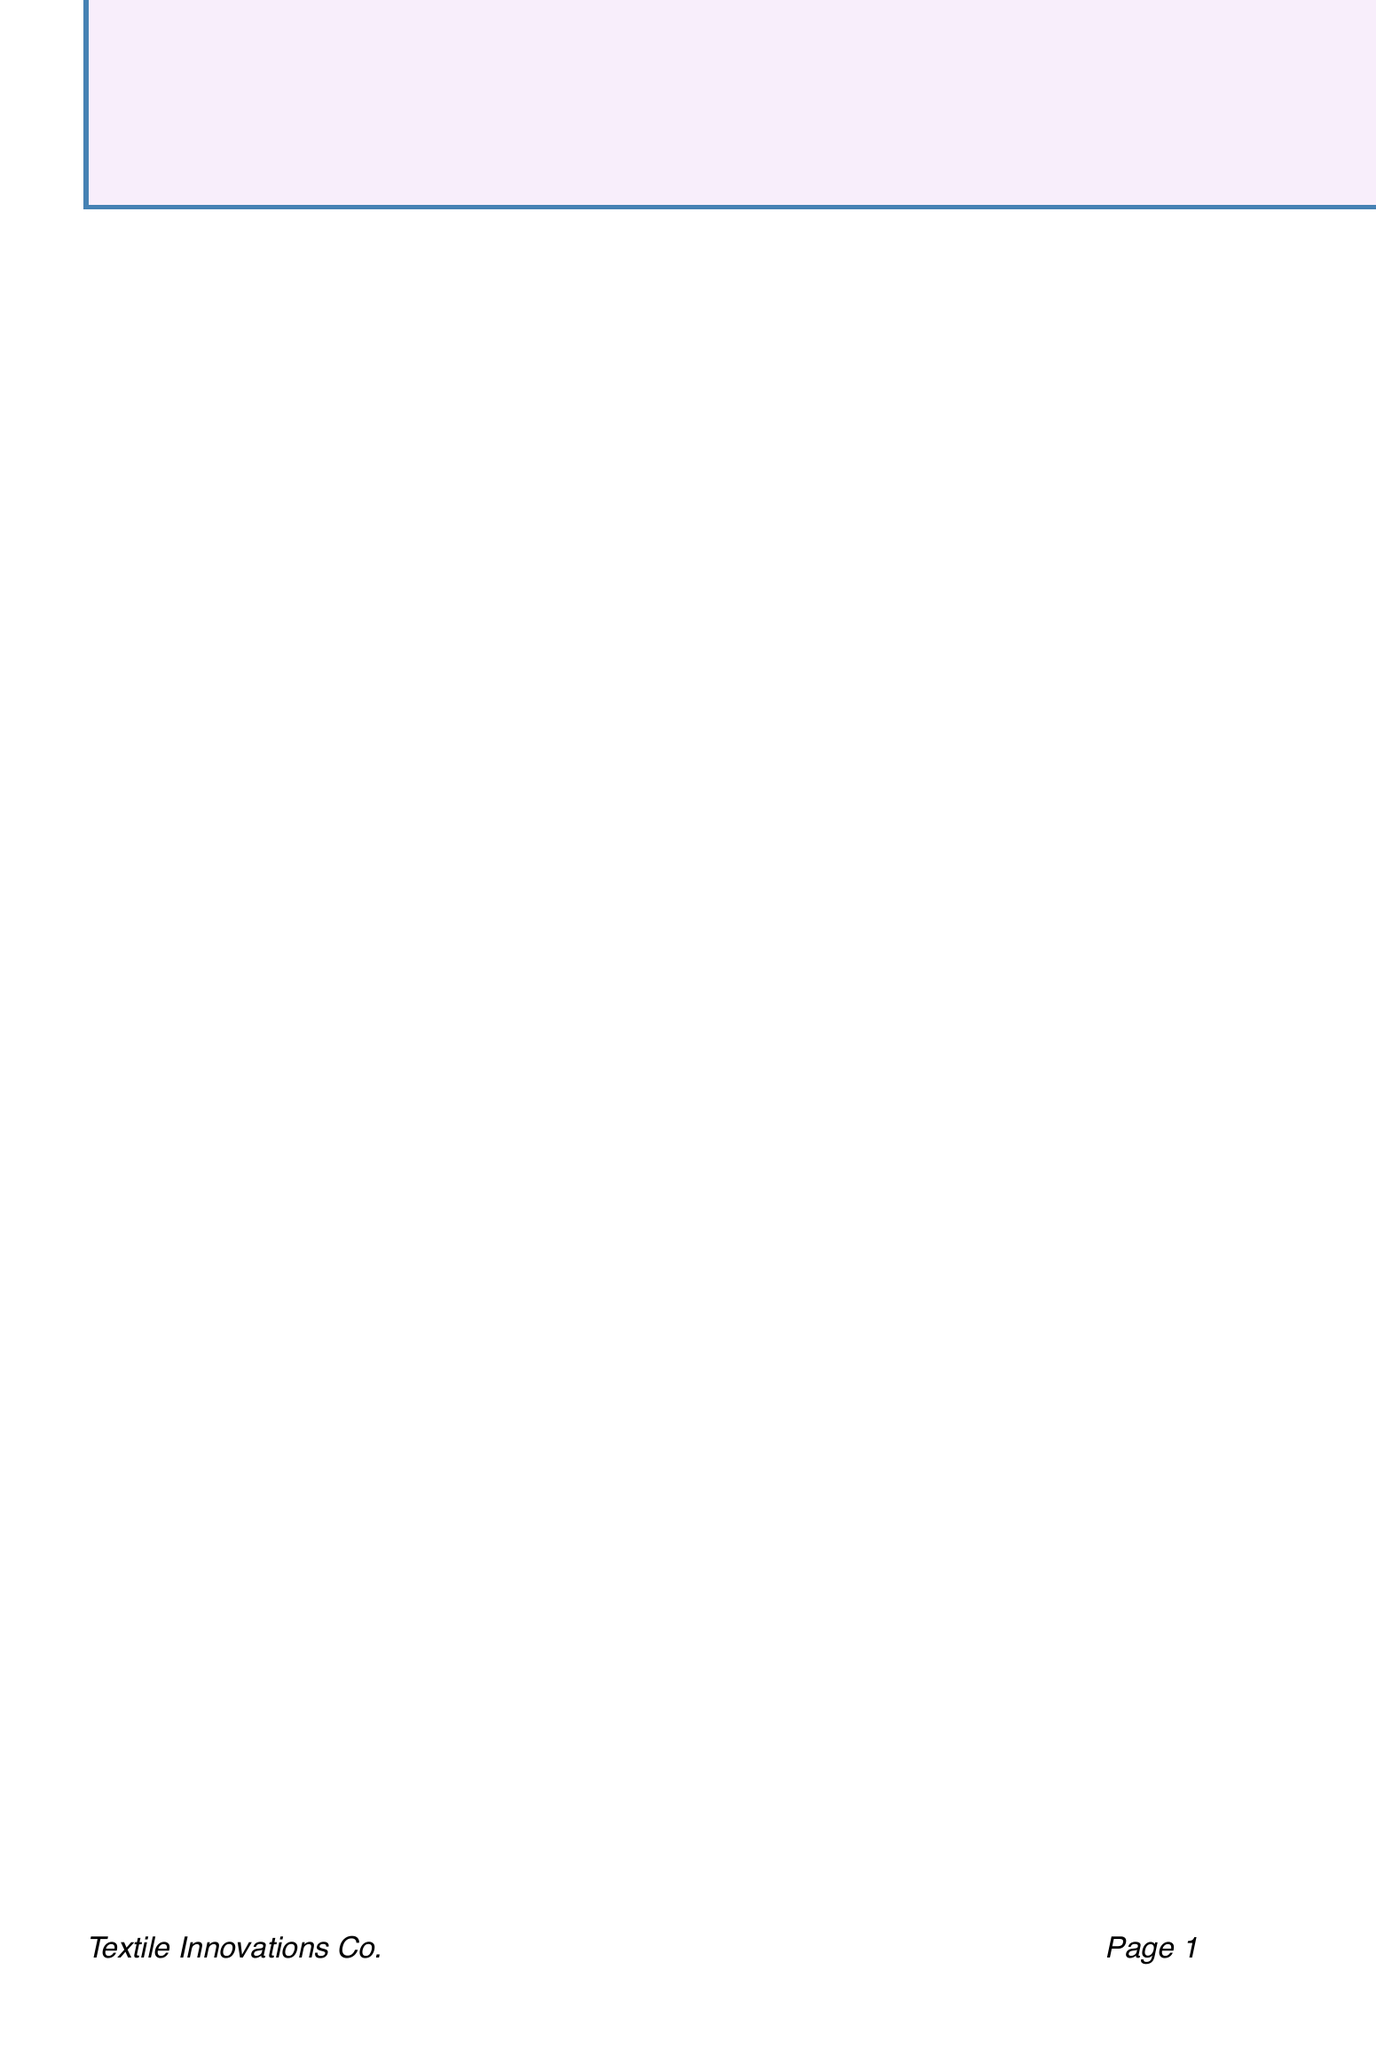What is the name of the sender? The sender's name is mentioned at the beginning of the letter.
Answer: Emma Patel What company does the sender represent? The company associated with the sender is listed in the sender's information.
Answer: Textile Innovations Co How many new patterns are introduced in the letter? The number of new patterns can be counted from the section that lists them.
Answer: Three What is the description of the "Eco-Luxe Linen" texture? The description is provided in the section that lists new textures and their details.
Answer: Sustainable linen blend with a subtle shimmer What is the special offer for first-time orders? The special offer for first-time orders is specified in the pricing information section.
Answer: 15% discount Which certification is mentioned in the sustainability section? The certifications are listed as a part of the sustainability information provided in the letter.
Answer: GOTS For which type of shoots is the "Floral Whisper" pattern best suited? This information is included in the suitability description of the pattern within its section.
Answer: Romantic, feminine looks What is the bulk order discount percentage mentioned? The percentage discount for bulk orders is stated in the pricing section.
Answer: 10% What is the call to action in the closing? The call to action is presented towards the end of the letter in the closing remarks.
Answer: Schedule a virtual meeting 